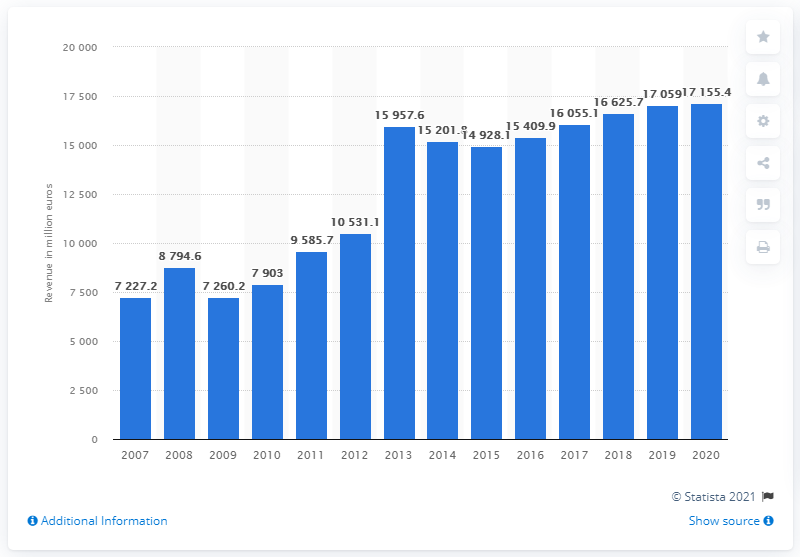Point out several critical features in this image. BayWa AG's revenue in 2020 was 17,155.4... BayWa's total revenue in 2007 was approximately 7,260.2... 